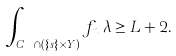<formula> <loc_0><loc_0><loc_500><loc_500>\int _ { C _ { n _ { i } } \cap ( \{ s \} \times Y ) } f _ { n _ { i } } \lambda \geq L + 2 .</formula> 